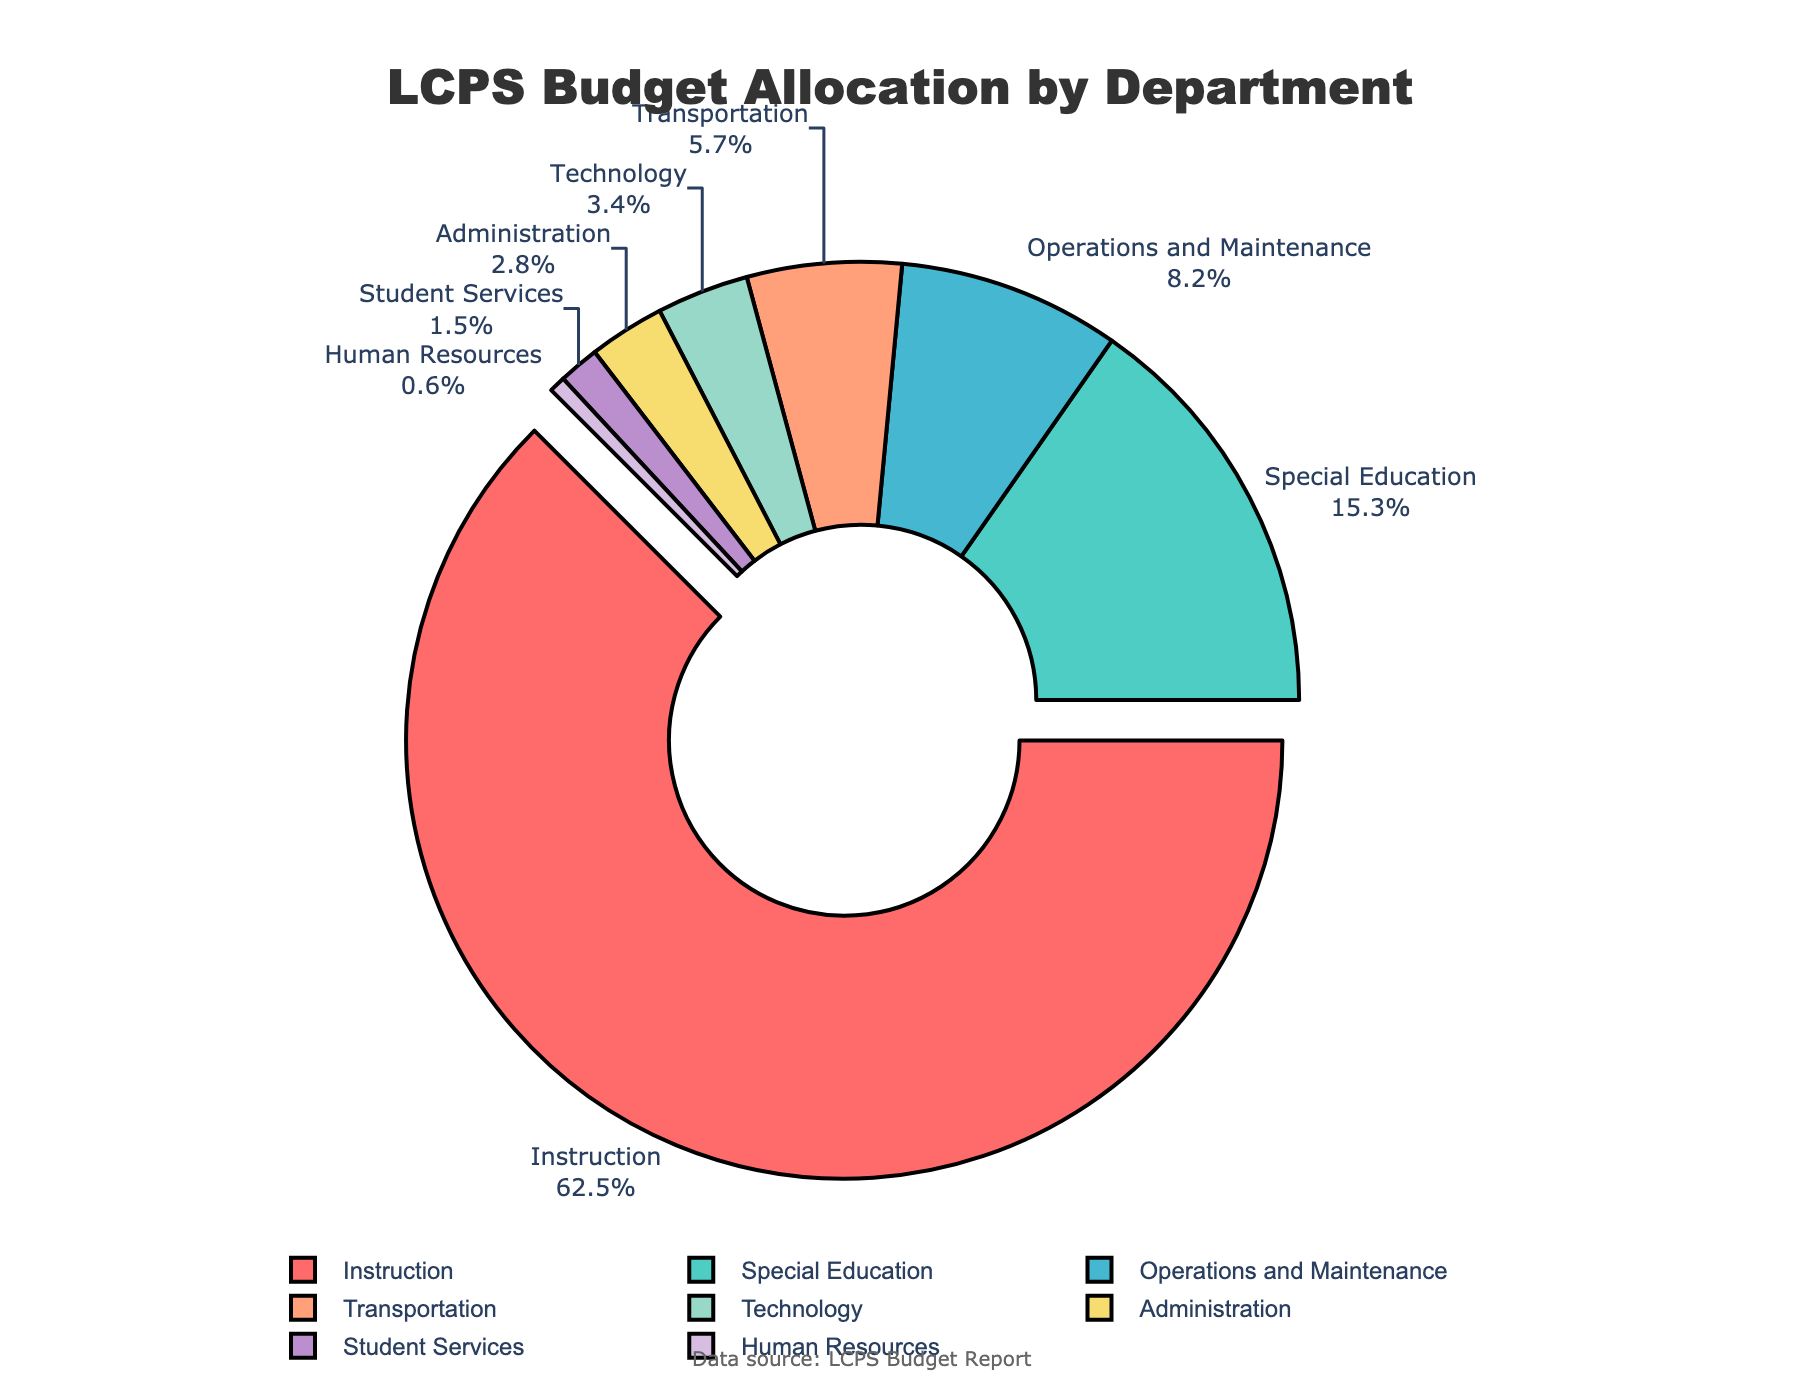How much budget is allocated to Instruction and Special Education combined? Instruction has 62.5% and Special Education has 15.3%. Combined, the allocation is 62.5 + 15.3 = 77.8%.
Answer: 77.8% Which department receives less budget allocation: Transportation or Technology? Transportation has 5.7% and Technology has 3.4%, so Technology receives less budget allocation.
Answer: Technology What color represents the Operations and Maintenance department in the pie chart? The Operations and Maintenance department is represented by the color assigned to it visually in the chart.
Answer: Light Blue What is the difference in budget allocation between Administration and Human Resources? Administration has 2.8% and Human Resources has 0.6%. The difference is 2.8 - 0.6 = 2.2%.
Answer: 2.2% Which department receives the highest budget allocation? The Instruction department, which is visually highlighted as the largest segment, receives the highest budget allocation of 62.5%.
Answer: Instruction What is the total budget allocation percentage for Technology and Student Services together? Technology has 3.4% and Student Services has 1.5%. Combined, it is 3.4 + 1.5 = 4.9%.
Answer: 4.9% Among the departments, which has the second highest budget allocation? The Special Education department, which is the second-largest segment, has the second highest budget allocation of 15.3%.
Answer: Special Education How many departments have a budget allocation of less than 5%? Transportation, Technology, Administration, Student Services, and Human Resources have allocations of 5.7%, 3.4%, 2.8%, 1.5%, and 0.6% respectively. Excluding Transportation, the other four are less than 5%.
Answer: 4 